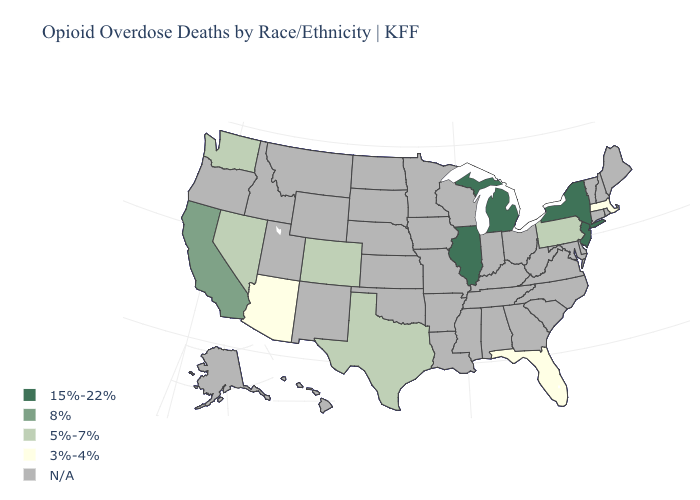What is the value of Washington?
Answer briefly. 5%-7%. How many symbols are there in the legend?
Give a very brief answer. 5. Does New Jersey have the lowest value in the Northeast?
Keep it brief. No. Which states have the lowest value in the USA?
Be succinct. Arizona, Florida, Massachusetts. What is the value of Connecticut?
Write a very short answer. N/A. Name the states that have a value in the range N/A?
Answer briefly. Alabama, Alaska, Arkansas, Connecticut, Delaware, Georgia, Hawaii, Idaho, Indiana, Iowa, Kansas, Kentucky, Louisiana, Maine, Maryland, Minnesota, Mississippi, Missouri, Montana, Nebraska, New Hampshire, New Mexico, North Carolina, North Dakota, Ohio, Oklahoma, Oregon, Rhode Island, South Carolina, South Dakota, Tennessee, Utah, Vermont, Virginia, West Virginia, Wisconsin, Wyoming. What is the highest value in the MidWest ?
Keep it brief. 15%-22%. What is the value of Kansas?
Short answer required. N/A. What is the lowest value in states that border Wyoming?
Be succinct. 5%-7%. Among the states that border Indiana , which have the highest value?
Keep it brief. Illinois, Michigan. Name the states that have a value in the range 3%-4%?
Short answer required. Arizona, Florida, Massachusetts. What is the lowest value in the Northeast?
Keep it brief. 3%-4%. What is the value of Rhode Island?
Quick response, please. N/A. 